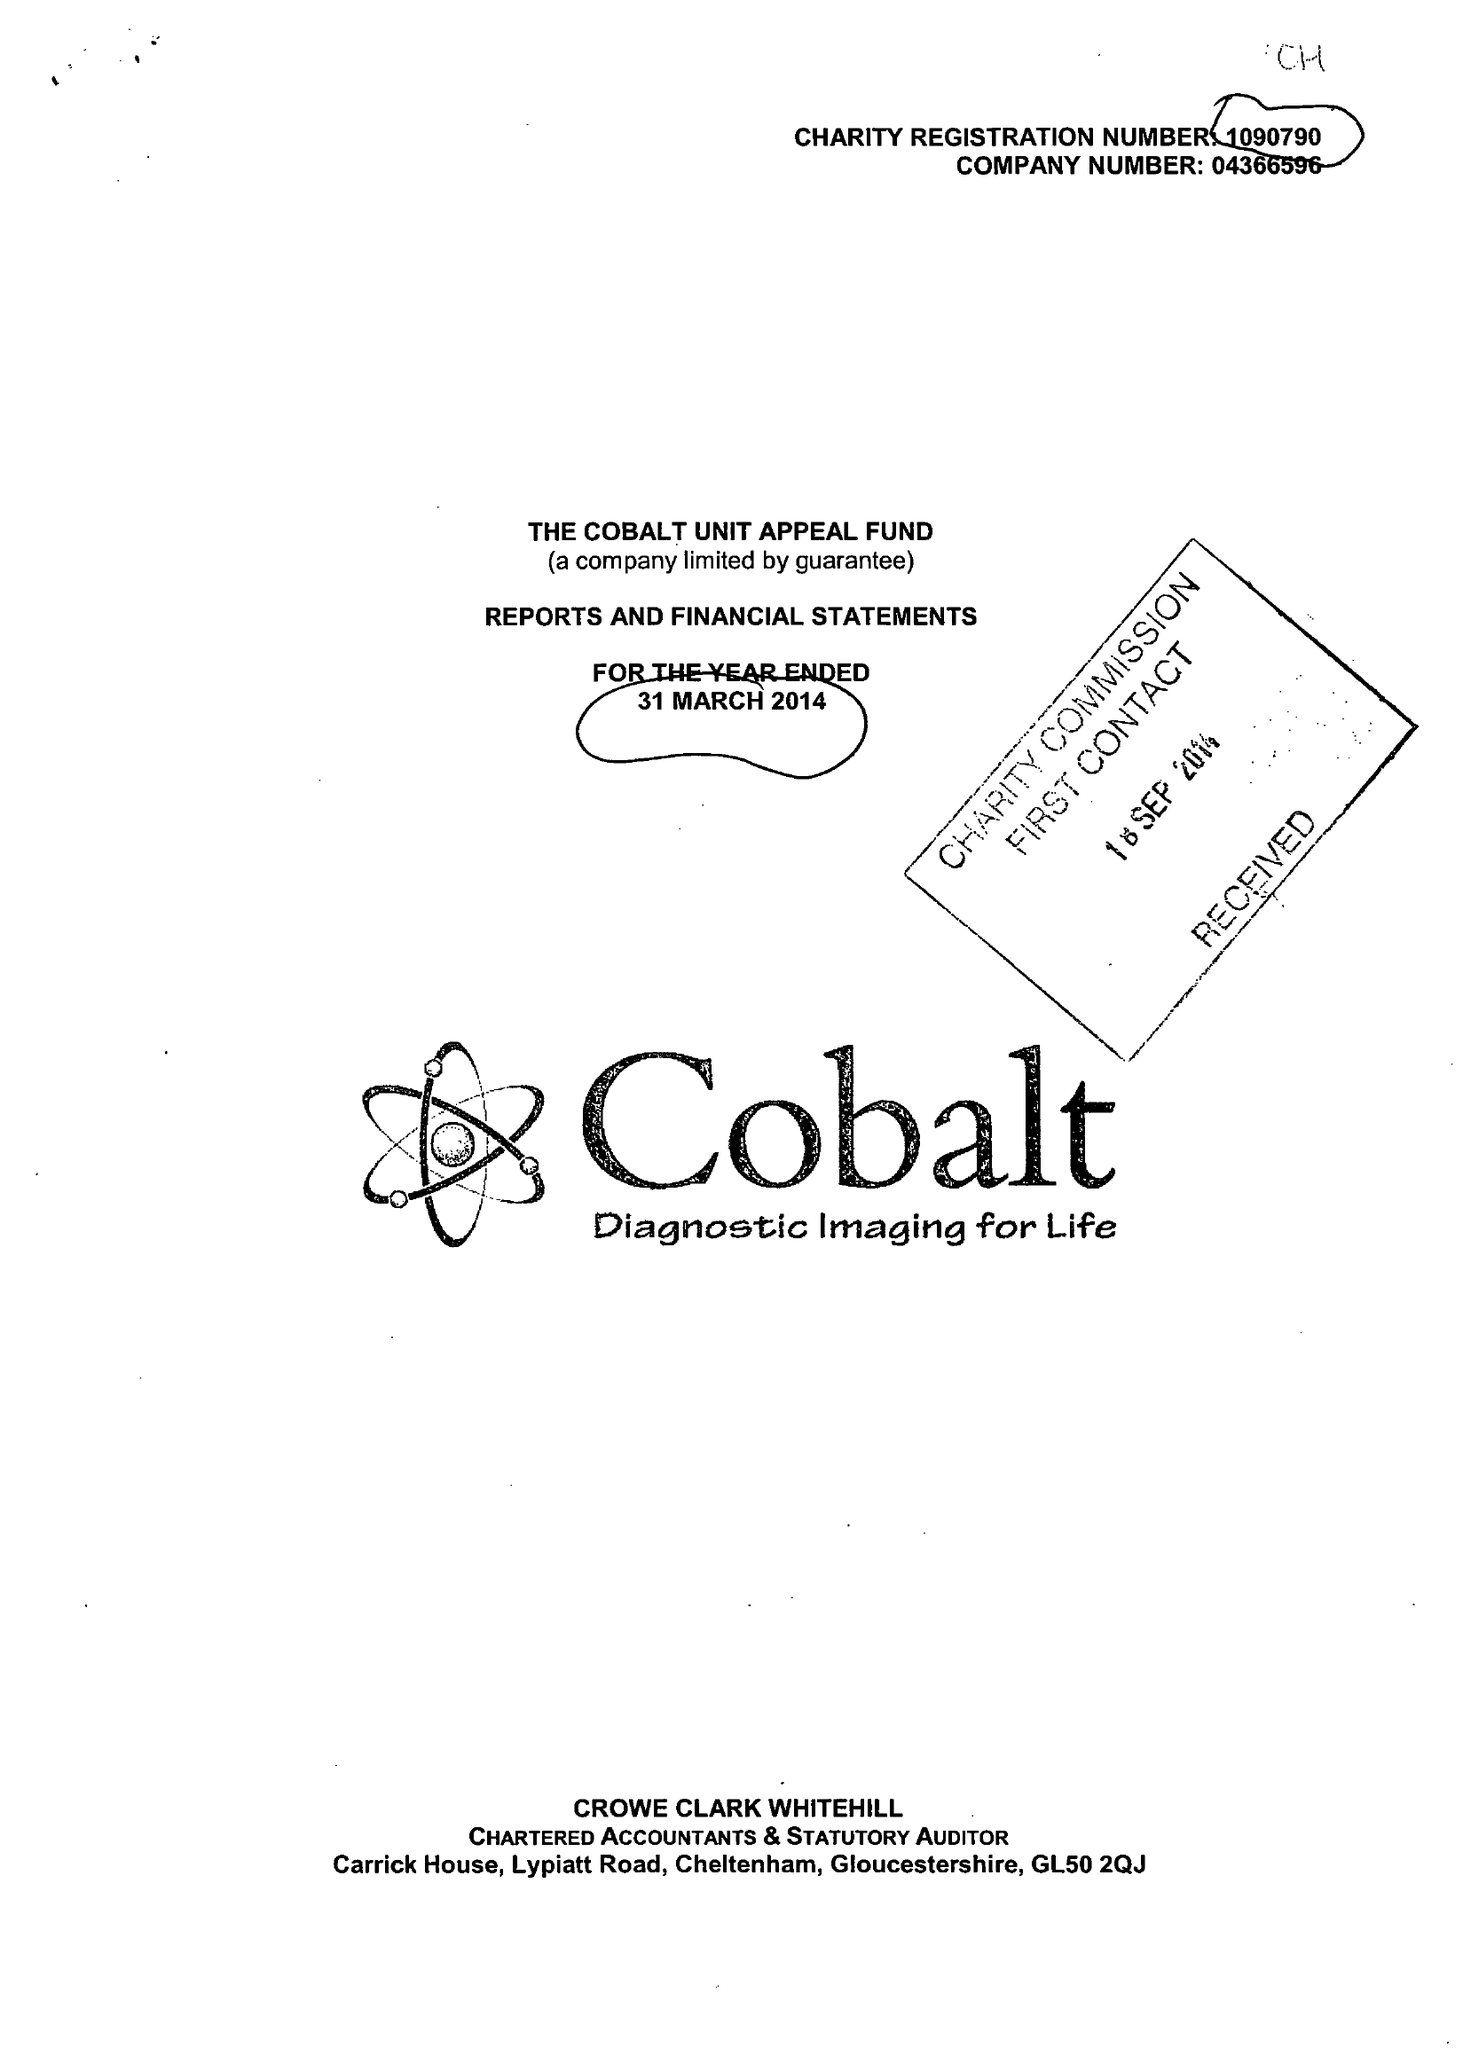What is the value for the address__postcode?
Answer the question using a single word or phrase. GL53 7AS 